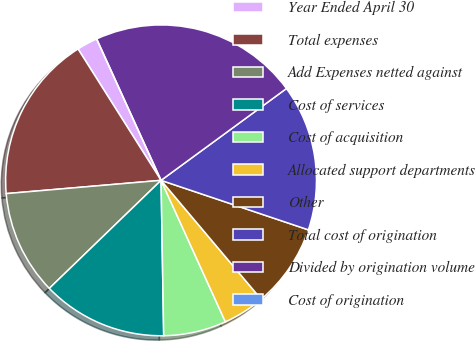<chart> <loc_0><loc_0><loc_500><loc_500><pie_chart><fcel>Year Ended April 30<fcel>Total expenses<fcel>Add Expenses netted against<fcel>Cost of services<fcel>Cost of acquisition<fcel>Allocated support departments<fcel>Other<fcel>Total cost of origination<fcel>Divided by origination volume<fcel>Cost of origination<nl><fcel>2.17%<fcel>17.39%<fcel>10.87%<fcel>13.04%<fcel>6.52%<fcel>4.35%<fcel>8.7%<fcel>15.22%<fcel>21.74%<fcel>0.0%<nl></chart> 